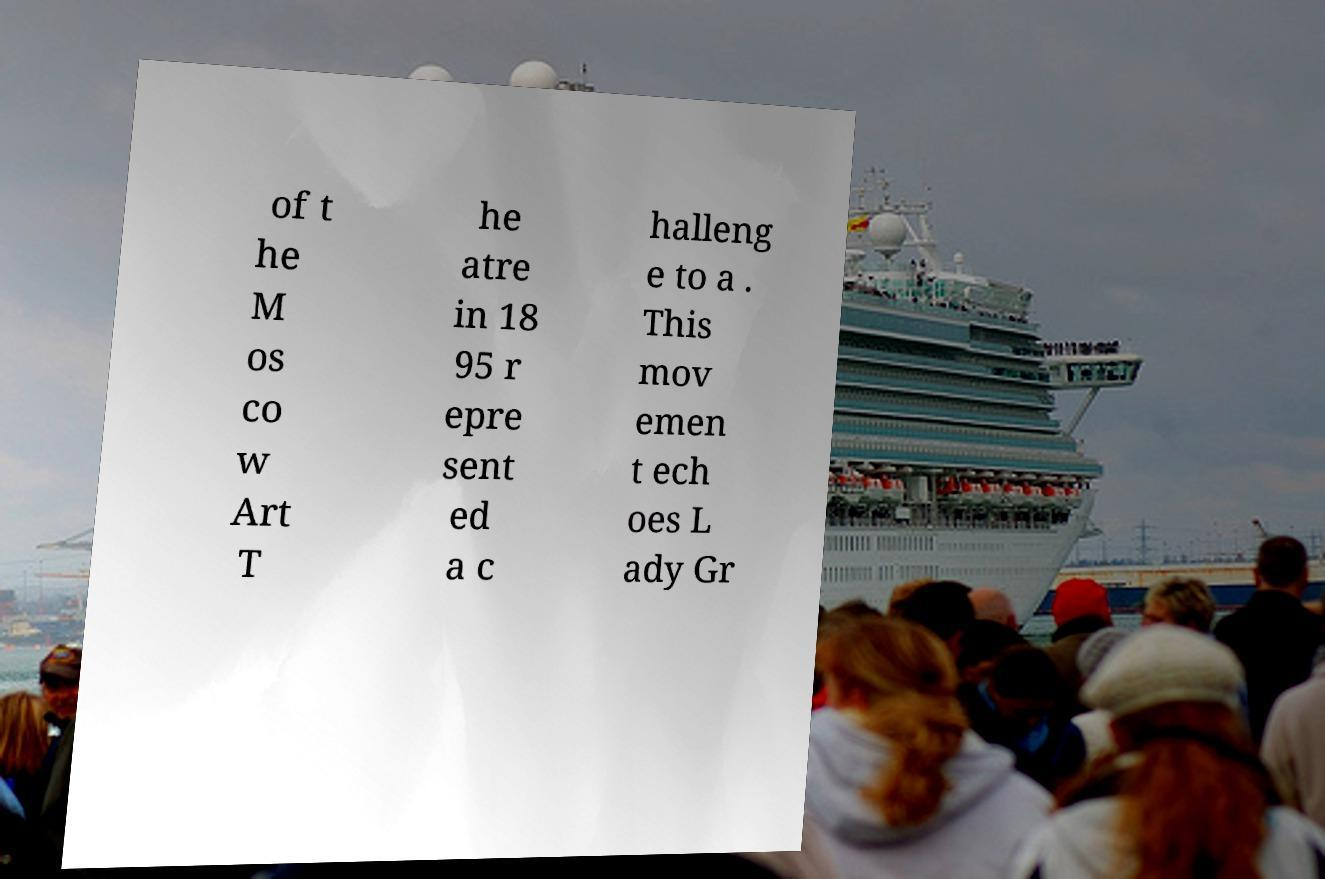What messages or text are displayed in this image? I need them in a readable, typed format. of t he M os co w Art T he atre in 18 95 r epre sent ed a c halleng e to a . This mov emen t ech oes L ady Gr 